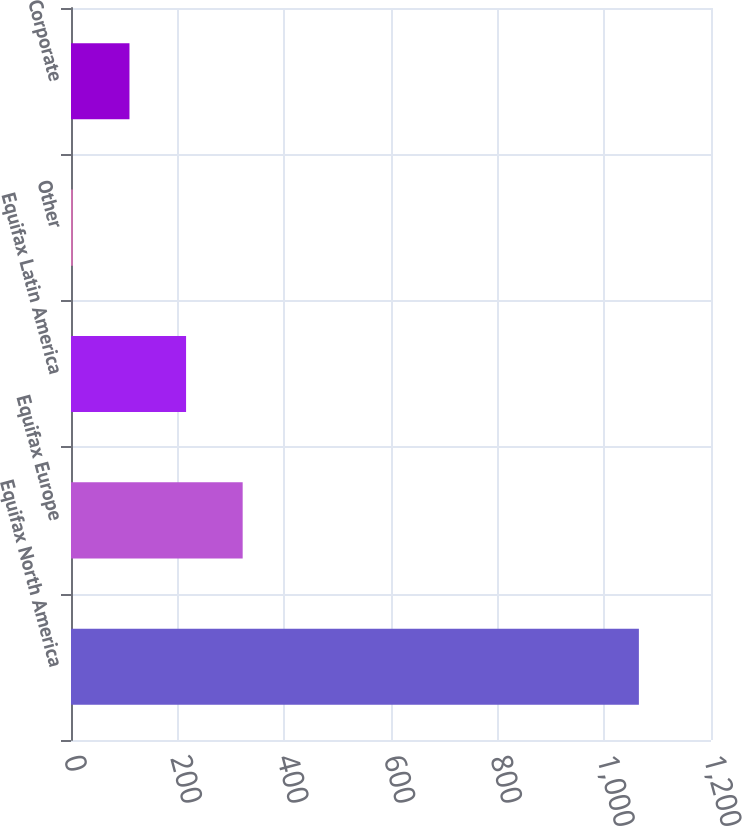Convert chart to OTSL. <chart><loc_0><loc_0><loc_500><loc_500><bar_chart><fcel>Equifax North America<fcel>Equifax Europe<fcel>Equifax Latin America<fcel>Other<fcel>Corporate<nl><fcel>1064.8<fcel>321.89<fcel>215.76<fcel>3.5<fcel>109.63<nl></chart> 